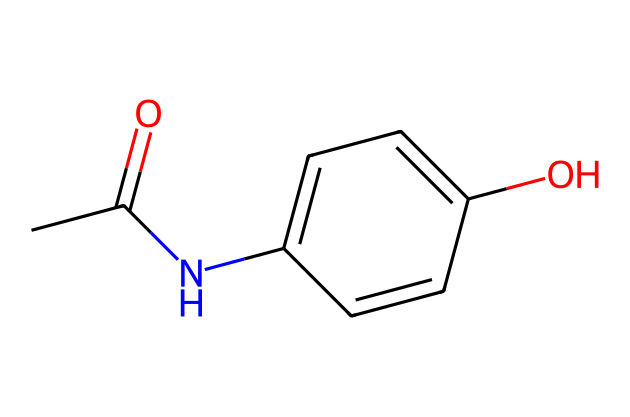What is the molecular formula of Paracetamol? To obtain the molecular formula, count the number of each type of atom in the SMILES string. The structure indicates there are 8 carbon atoms (C), 9 hydrogen atoms (H), 1 nitrogen atom (N), and 2 oxygen atoms (O), leading to the formula C8H9NO2.
Answer: C8H9NO2 How many rings are present in the structure? Analyzing the SMILES code, we identify that "C1=CC=C" indicates the presence of a cyclic structure. There is one ring present in the Paracetamol's structure.
Answer: 1 What functional groups are present in Paracetamol? The SMILES structure suggests the presence of an amide group (due to the "NC(=O)" part) and a phenolic hydroxyl group (due to the "C=C(C=C1)O" part), indicating that these functional groups play a role in the drug's properties.
Answer: amide and phenol What type of compound is Paracetamol classified as? Looking at the structure, with a nitrogen atom and the presence of an active site for pain relief, it is classified as an analgesic and antipyretic compound.
Answer: analgesic and antipyretic How many oxygen atoms are in Paracetamol? From the molecular formula derived from the SMILES representation, it contains 2 oxygen atoms as indicated by "O" twice in the structure.
Answer: 2 Which part of the structure is responsible for pain relief? Paracetamol's pain relief activity is closely associated with the "acetaminophen" portion of the structure, specifically the amide functional group. This group interacts with pain-mediating pathways in the body.
Answer: amide functional group 